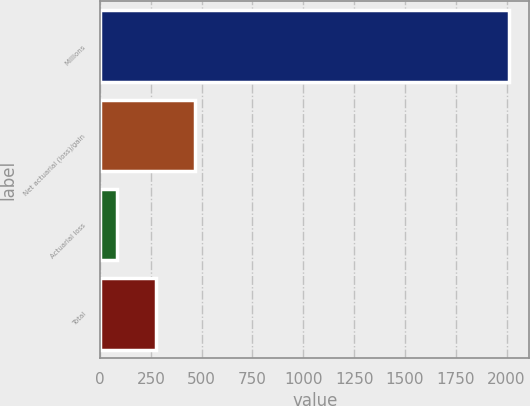Convert chart. <chart><loc_0><loc_0><loc_500><loc_500><bar_chart><fcel>Millions<fcel>Net actuarial (loss)/gain<fcel>Actuarial loss<fcel>Total<nl><fcel>2012<fcel>468.8<fcel>83<fcel>275.9<nl></chart> 